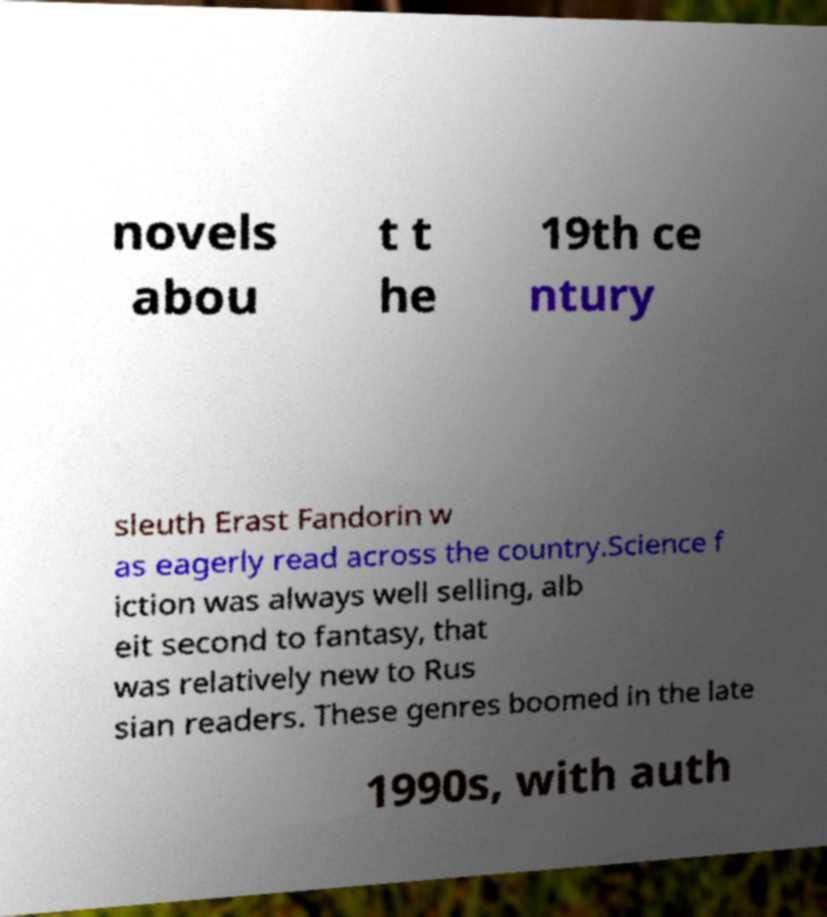Please identify and transcribe the text found in this image. novels abou t t he 19th ce ntury sleuth Erast Fandorin w as eagerly read across the country.Science f iction was always well selling, alb eit second to fantasy, that was relatively new to Rus sian readers. These genres boomed in the late 1990s, with auth 